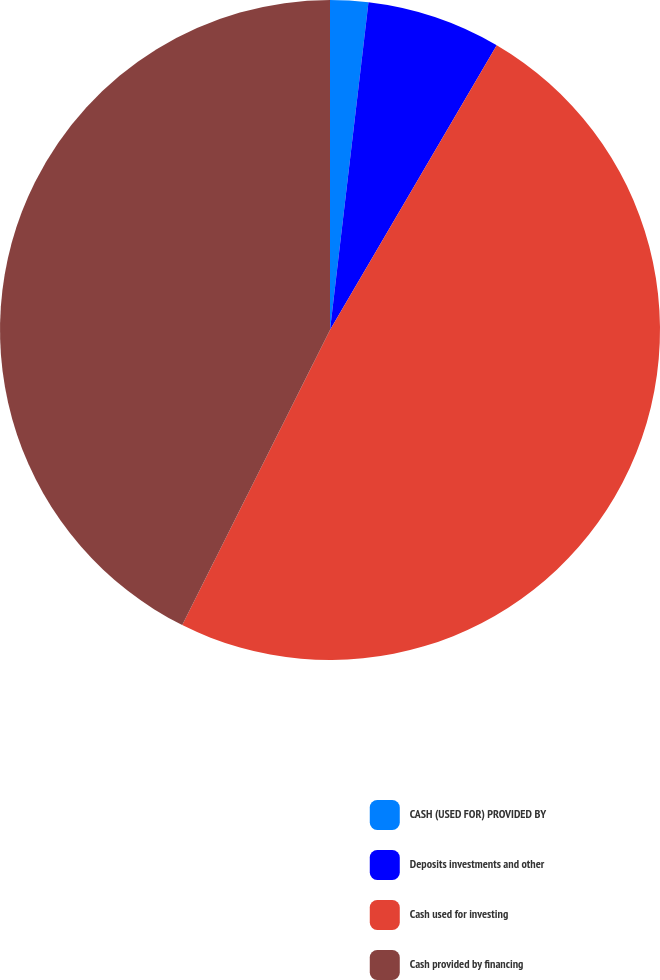<chart> <loc_0><loc_0><loc_500><loc_500><pie_chart><fcel>CASH (USED FOR) PROVIDED BY<fcel>Deposits investments and other<fcel>Cash used for investing<fcel>Cash provided by financing<nl><fcel>1.86%<fcel>6.57%<fcel>48.96%<fcel>42.61%<nl></chart> 